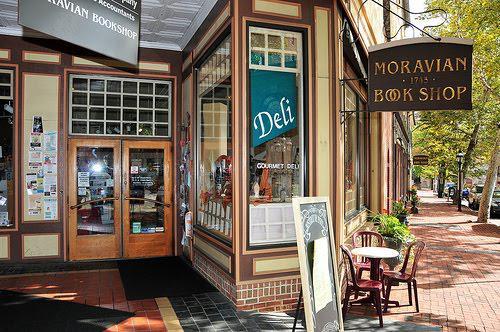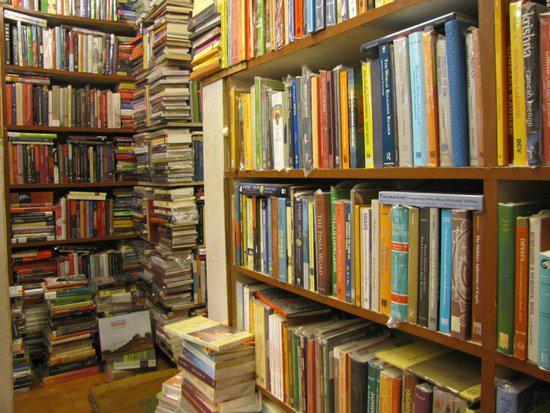The first image is the image on the left, the second image is the image on the right. Assess this claim about the two images: "One image shows the exterior of a book shop.". Correct or not? Answer yes or no. Yes. The first image is the image on the left, the second image is the image on the right. Considering the images on both sides, is "One of the images shows the outside of a bookstore." valid? Answer yes or no. Yes. 